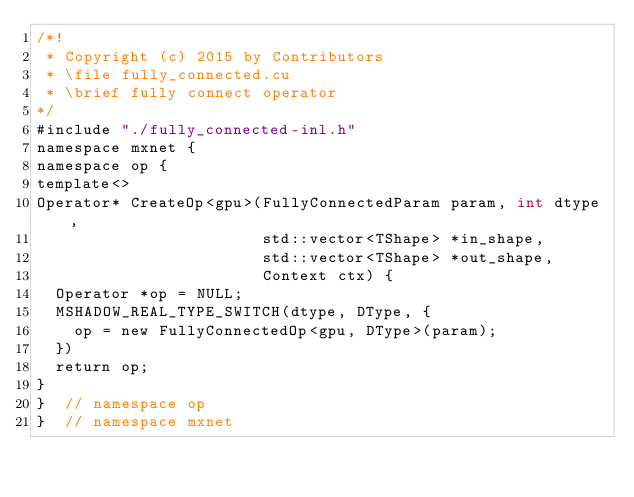<code> <loc_0><loc_0><loc_500><loc_500><_Cuda_>/*!
 * Copyright (c) 2015 by Contributors
 * \file fully_connected.cu
 * \brief fully connect operator
*/
#include "./fully_connected-inl.h"
namespace mxnet {
namespace op {
template<>
Operator* CreateOp<gpu>(FullyConnectedParam param, int dtype,
                        std::vector<TShape> *in_shape,
                        std::vector<TShape> *out_shape,
                        Context ctx) {
  Operator *op = NULL;
  MSHADOW_REAL_TYPE_SWITCH(dtype, DType, {
    op = new FullyConnectedOp<gpu, DType>(param);
  })
  return op;
}
}  // namespace op
}  // namespace mxnet
</code> 